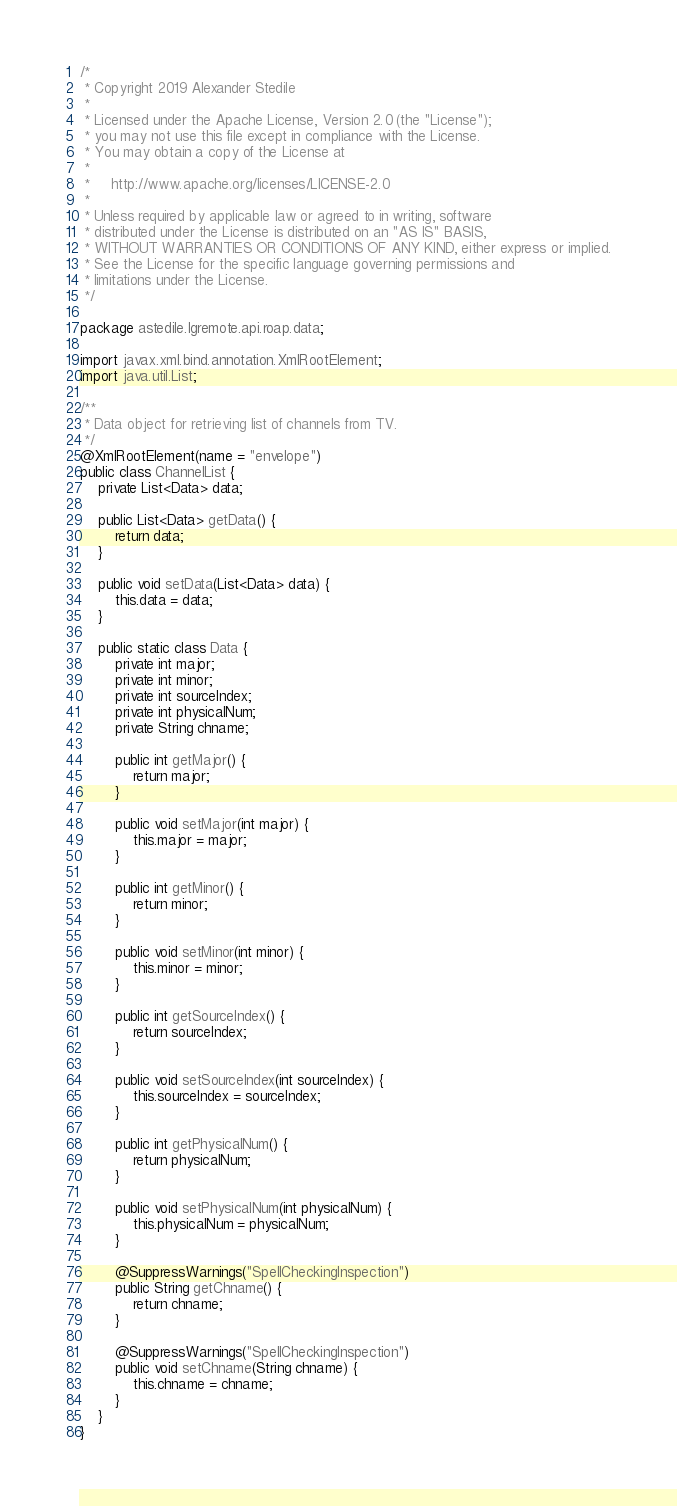<code> <loc_0><loc_0><loc_500><loc_500><_Java_>/*
 * Copyright 2019 Alexander Stedile
 *
 * Licensed under the Apache License, Version 2.0 (the "License");
 * you may not use this file except in compliance with the License.
 * You may obtain a copy of the License at
 *
 *     http://www.apache.org/licenses/LICENSE-2.0
 *
 * Unless required by applicable law or agreed to in writing, software
 * distributed under the License is distributed on an "AS IS" BASIS,
 * WITHOUT WARRANTIES OR CONDITIONS OF ANY KIND, either express or implied.
 * See the License for the specific language governing permissions and
 * limitations under the License.
 */

package astedile.lgremote.api.roap.data;

import javax.xml.bind.annotation.XmlRootElement;
import java.util.List;

/**
 * Data object for retrieving list of channels from TV.
 */
@XmlRootElement(name = "envelope")
public class ChannelList {
    private List<Data> data;

    public List<Data> getData() {
        return data;
    }

    public void setData(List<Data> data) {
        this.data = data;
    }

    public static class Data {
        private int major;
        private int minor;
        private int sourceIndex;
        private int physicalNum;
        private String chname;

        public int getMajor() {
            return major;
        }

        public void setMajor(int major) {
            this.major = major;
        }

        public int getMinor() {
            return minor;
        }

        public void setMinor(int minor) {
            this.minor = minor;
        }

        public int getSourceIndex() {
            return sourceIndex;
        }

        public void setSourceIndex(int sourceIndex) {
            this.sourceIndex = sourceIndex;
        }

        public int getPhysicalNum() {
            return physicalNum;
        }

        public void setPhysicalNum(int physicalNum) {
            this.physicalNum = physicalNum;
        }

        @SuppressWarnings("SpellCheckingInspection")
        public String getChname() {
            return chname;
        }

        @SuppressWarnings("SpellCheckingInspection")
        public void setChname(String chname) {
            this.chname = chname;
        }
    }
}
</code> 